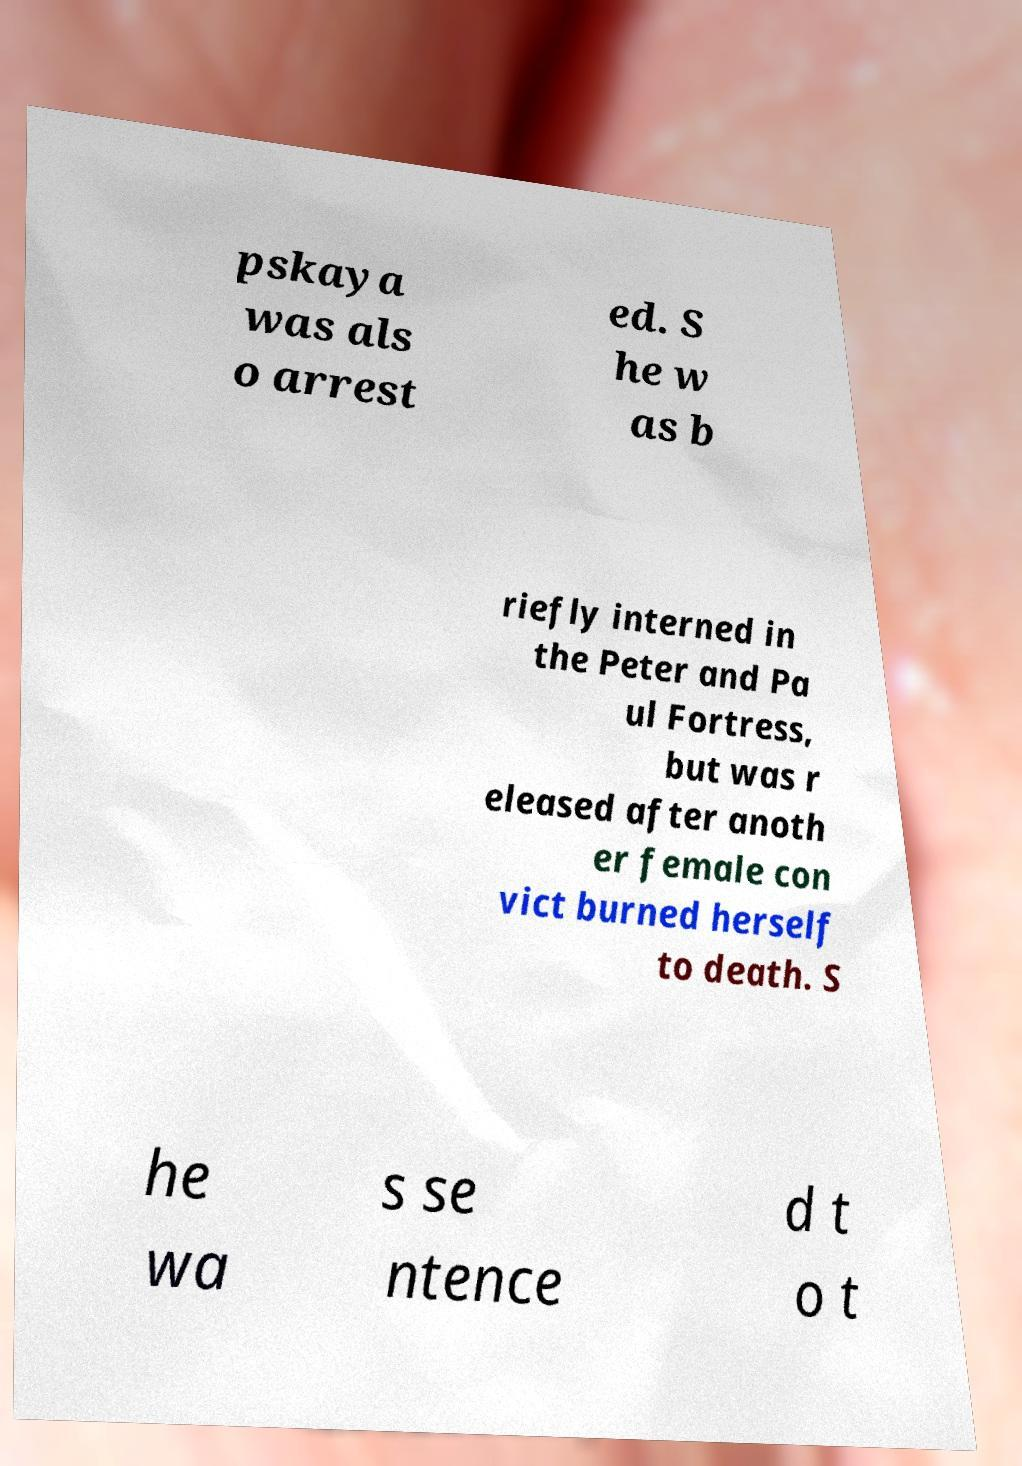There's text embedded in this image that I need extracted. Can you transcribe it verbatim? pskaya was als o arrest ed. S he w as b riefly interned in the Peter and Pa ul Fortress, but was r eleased after anoth er female con vict burned herself to death. S he wa s se ntence d t o t 